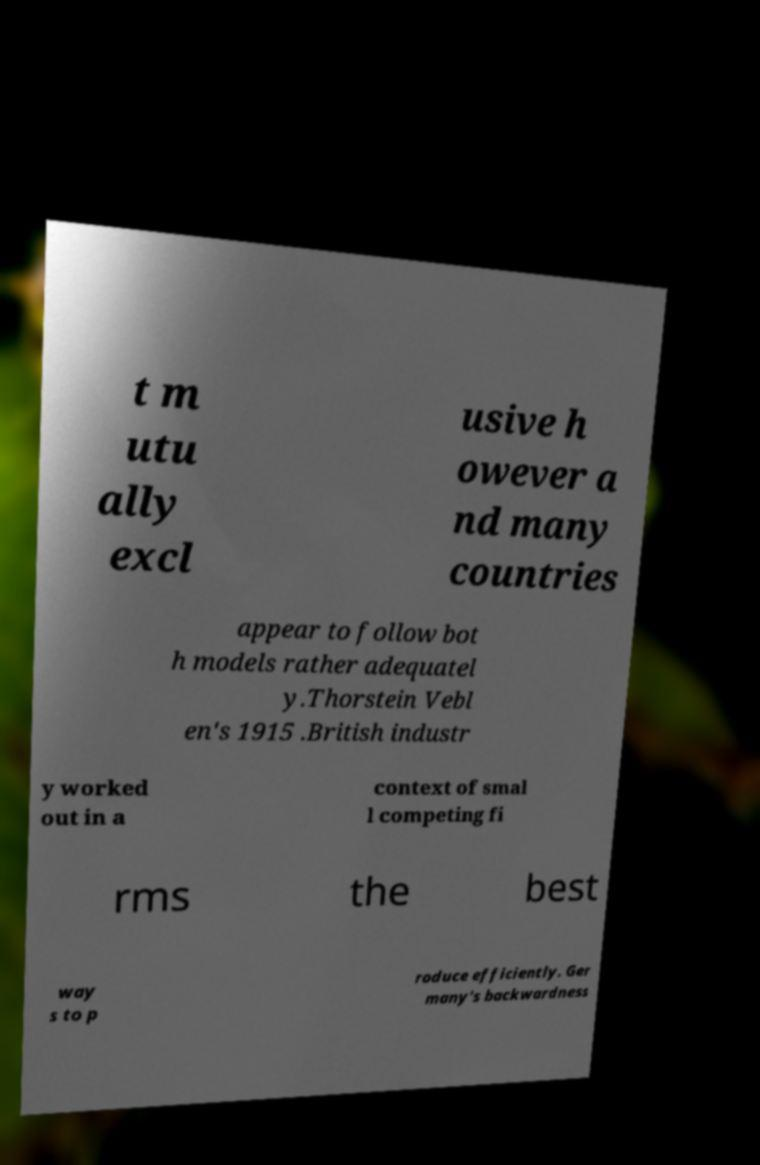What messages or text are displayed in this image? I need them in a readable, typed format. t m utu ally excl usive h owever a nd many countries appear to follow bot h models rather adequatel y.Thorstein Vebl en's 1915 .British industr y worked out in a context of smal l competing fi rms the best way s to p roduce efficiently. Ger many's backwardness 